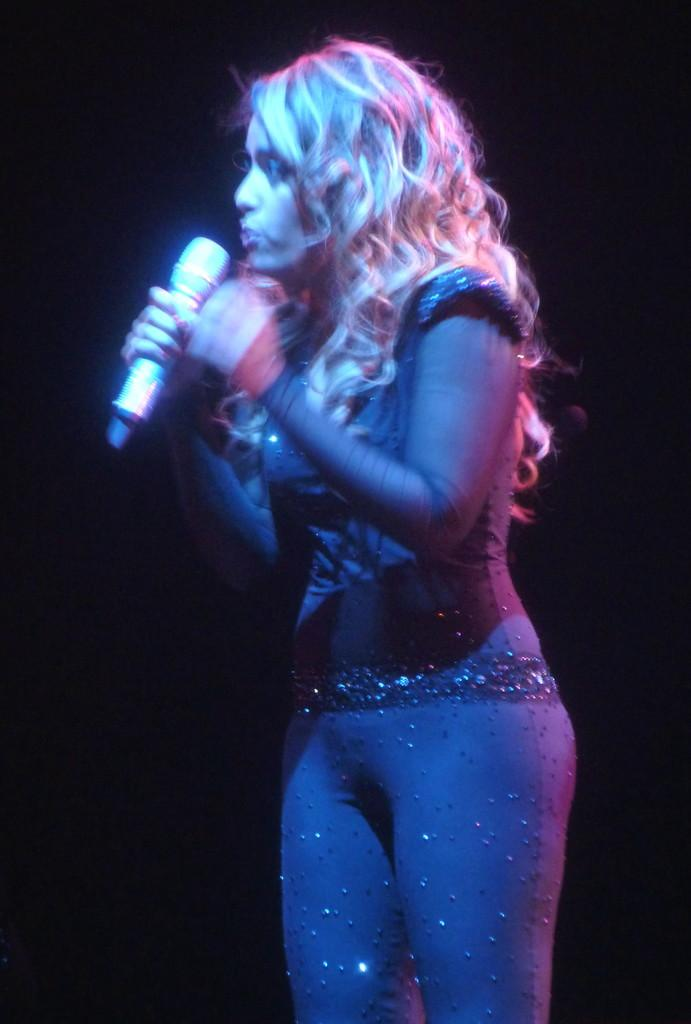What is the color of the background in the image? The background of the picture is dark. What is the woman in the image doing? The woman is singing and holding a musical instrument. What is the woman wearing in the image? The woman is wearing a black dress. What month is the committee meeting scheduled for in the image? There is no mention of a committee or a meeting in the image, so it is not possible to determine the month of any scheduled meeting. 